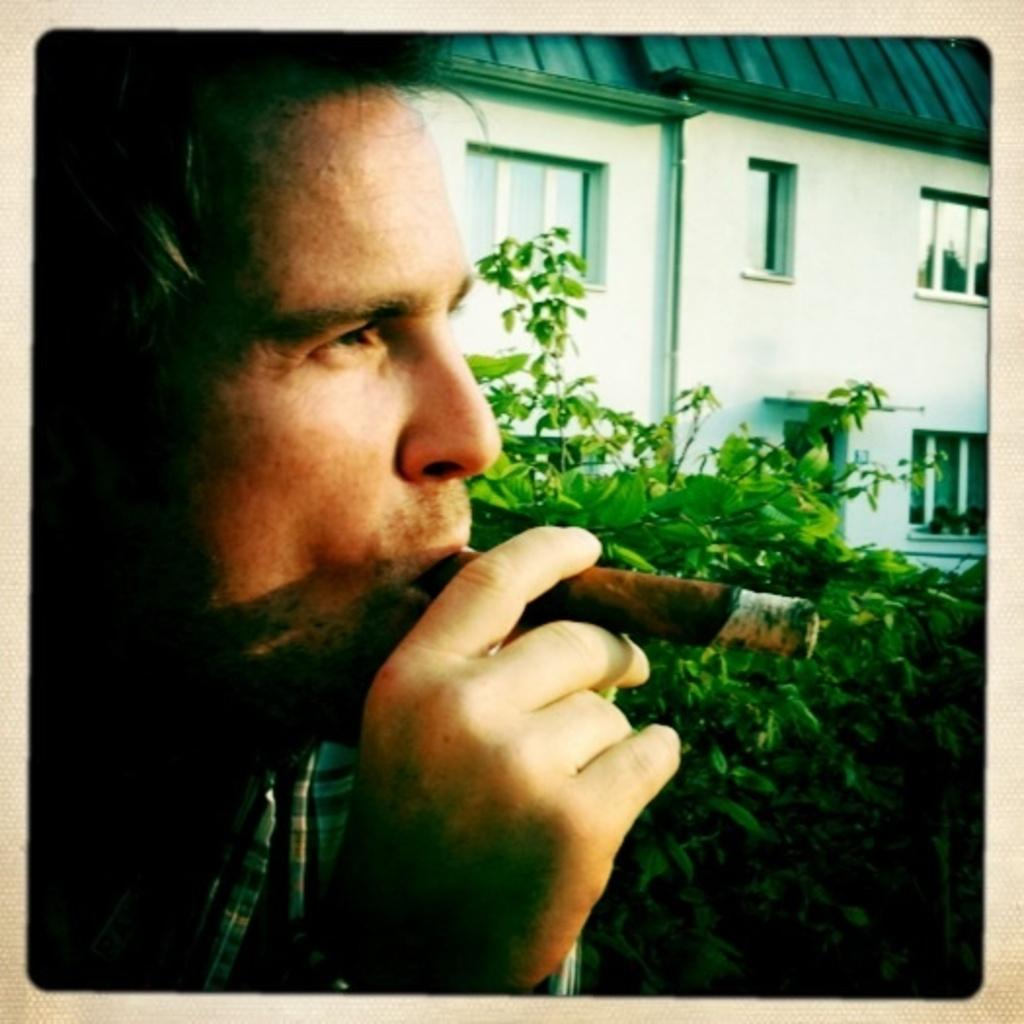What is the man in the image doing? The man in the image has a cigar in his mouth and is holding it. What can be seen in the background of the image? There are plants and a building with windows in the background of the image. What type of attack is the man planning in the image? There is no indication of an attack or any aggressive behavior in the image. The man is simply holding a cigar in his mouth. 